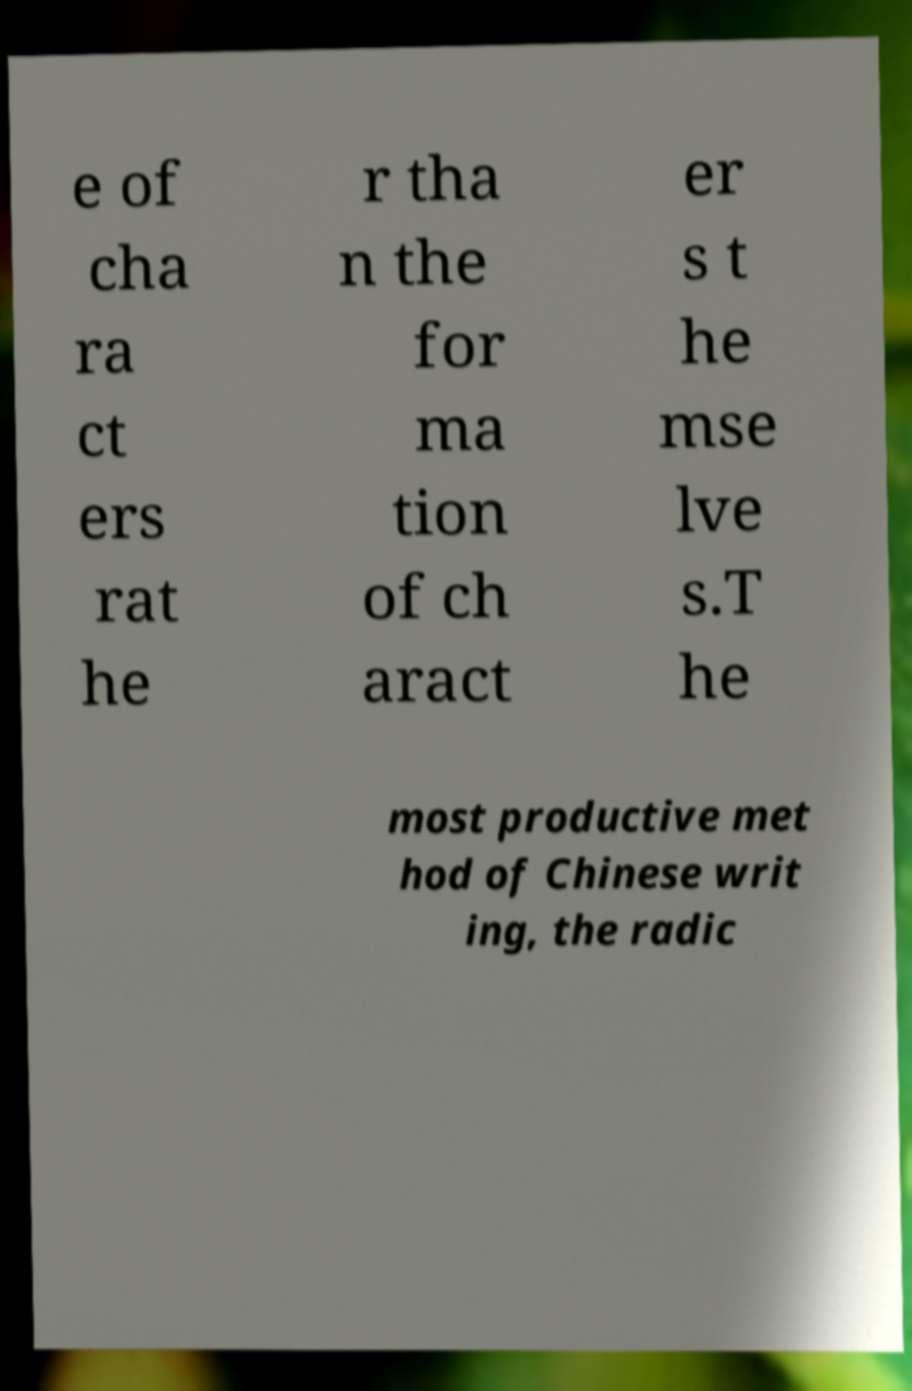I need the written content from this picture converted into text. Can you do that? e of cha ra ct ers rat he r tha n the for ma tion of ch aract er s t he mse lve s.T he most productive met hod of Chinese writ ing, the radic 